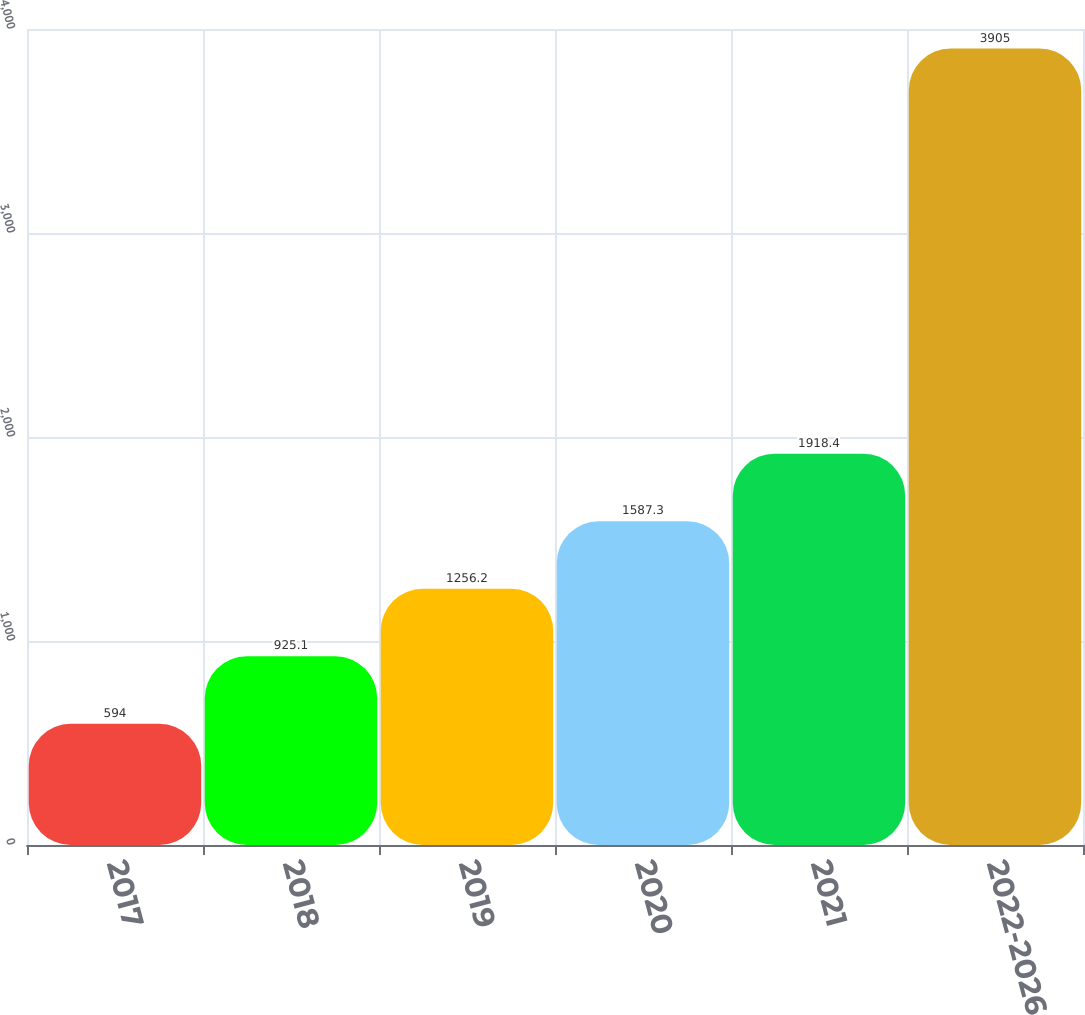Convert chart to OTSL. <chart><loc_0><loc_0><loc_500><loc_500><bar_chart><fcel>2017<fcel>2018<fcel>2019<fcel>2020<fcel>2021<fcel>2022-2026<nl><fcel>594<fcel>925.1<fcel>1256.2<fcel>1587.3<fcel>1918.4<fcel>3905<nl></chart> 